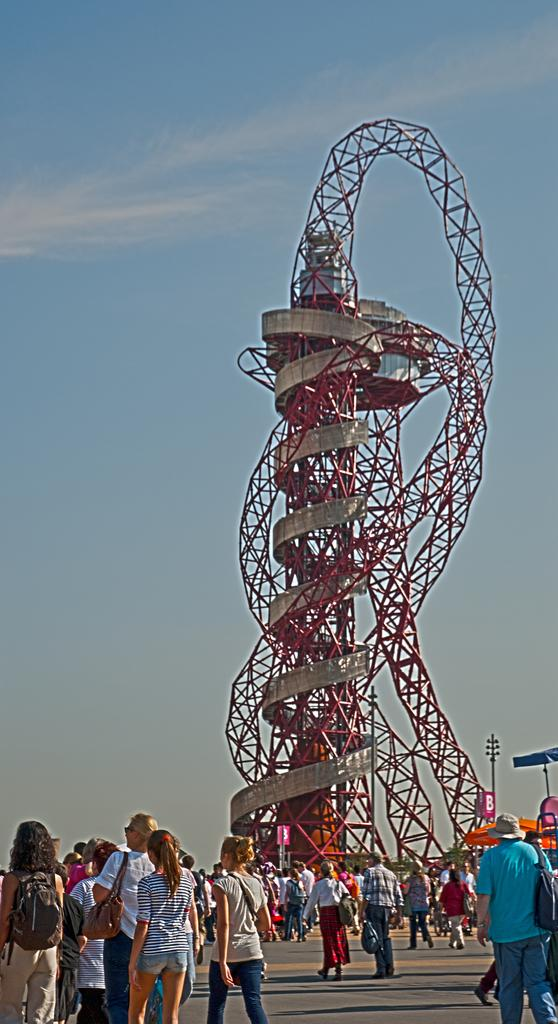What is the main structure in the center of the image? There is a tower in the center of the image. Who or what is located at the bottom of the image? There are people at the bottom of the image. What can be seen on the right side of the image? There are poles on the right side of the image. What is visible in the background of the image? The sky and trees are visible in the background of the image. What type of activity is the eye performing in the image? There is no eye present in the image, so it is not possible to answer that question. 